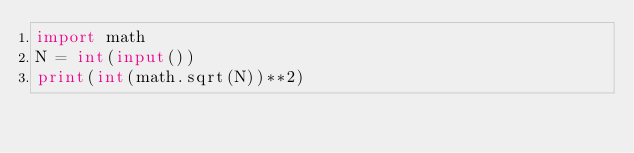Convert code to text. <code><loc_0><loc_0><loc_500><loc_500><_Python_>import math
N = int(input())
print(int(math.sqrt(N))**2)</code> 